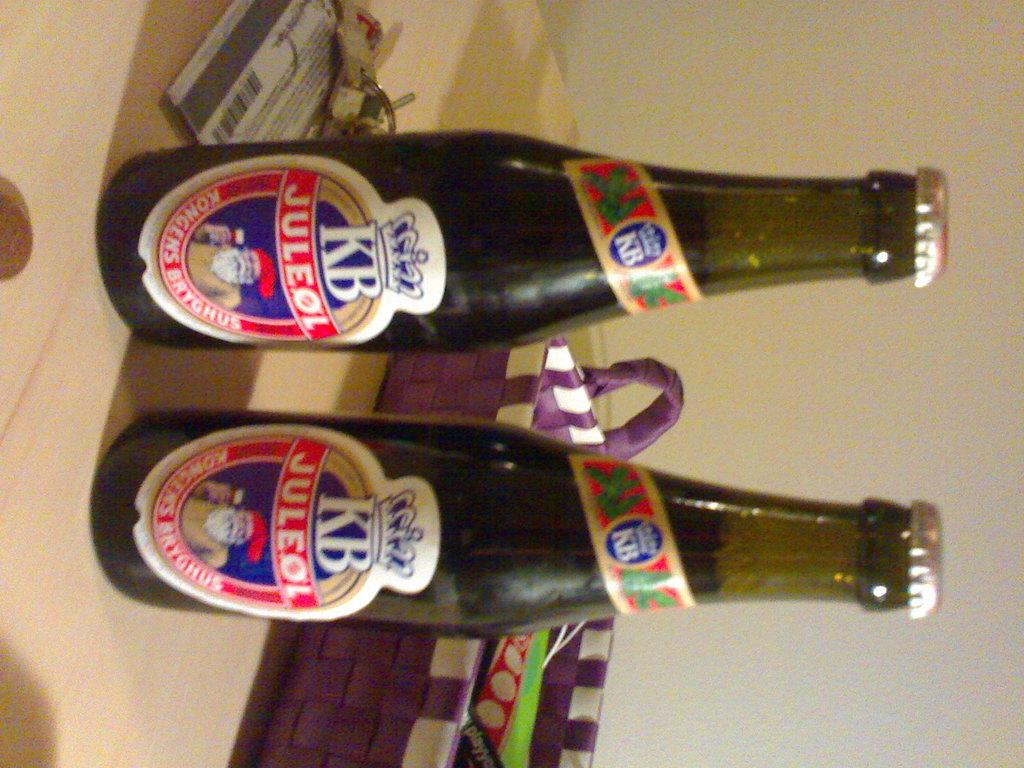<image>
Provide a brief description of the given image. Two bottles of KB lager sit on a table in front of a purple basket 